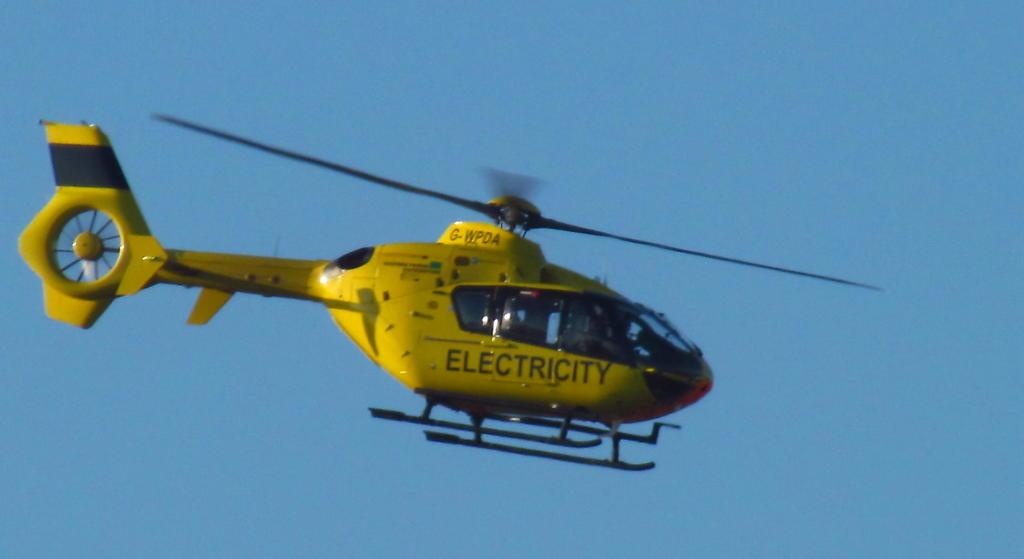What is the main subject of the image? The main subject of the image is a helicopter. Can you describe the position of the helicopter in the image? The helicopter is in the air in the image. What color is the sky visible in the background of the image? The sky visible in the background of the image is blue. Can you tell me how many kittens are sitting on the base of the helicopter in the image? There are no kittens or bases present in the image; it features a helicopter in the air against a blue sky. 